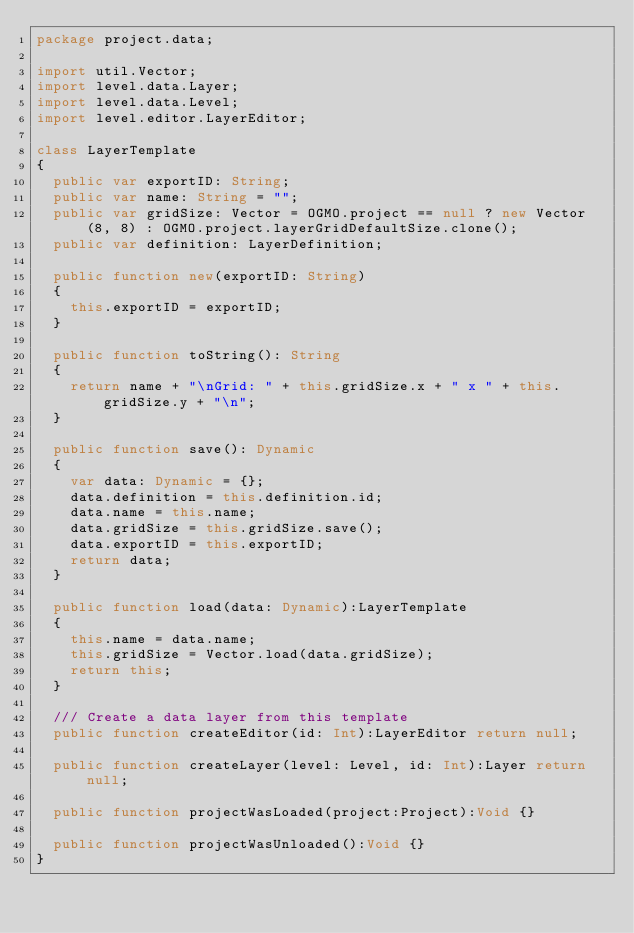<code> <loc_0><loc_0><loc_500><loc_500><_Haxe_>package project.data;

import util.Vector;
import level.data.Layer;
import level.data.Level;
import level.editor.LayerEditor;

class LayerTemplate
{
  public var exportID: String;
  public var name: String = "";
  public var gridSize: Vector = OGMO.project == null ? new Vector(8, 8) : OGMO.project.layerGridDefaultSize.clone();
  public var definition: LayerDefinition;

  public function new(exportID: String)
  {
    this.exportID = exportID;
  }

  public function toString(): String
  {
    return name + "\nGrid: " + this.gridSize.x + " x " + this.gridSize.y + "\n";
  }

  public function save(): Dynamic
  {
    var data: Dynamic = {};
    data.definition = this.definition.id;
    data.name = this.name;
    data.gridSize = this.gridSize.save();
    data.exportID = this.exportID;
    return data;
  }

  public function load(data: Dynamic):LayerTemplate
  {
    this.name = data.name;
    this.gridSize = Vector.load(data.gridSize);
    return this;
  }

  /// Create a data layer from this template
  public function createEditor(id: Int):LayerEditor return null;
  
  public function createLayer(level: Level, id: Int):Layer return null;

  public function projectWasLoaded(project:Project):Void {}

  public function projectWasUnloaded():Void {}
}
</code> 